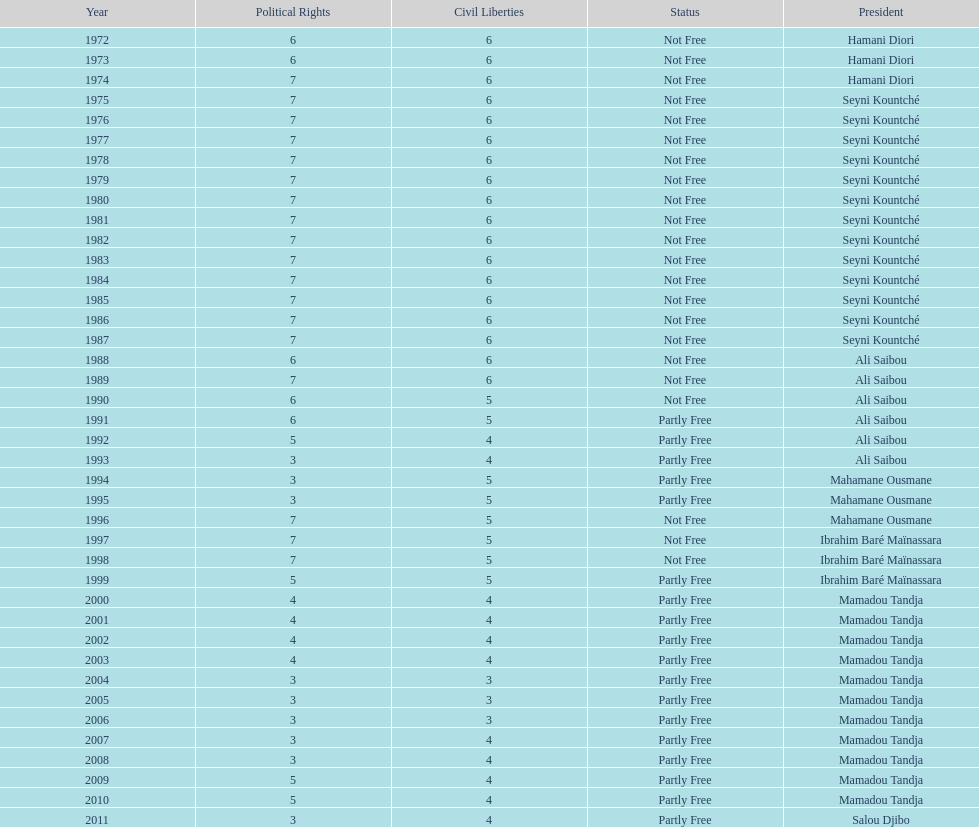Between ali saibou and mamadou tandja, who governed for a longer period? Mamadou Tandja. 